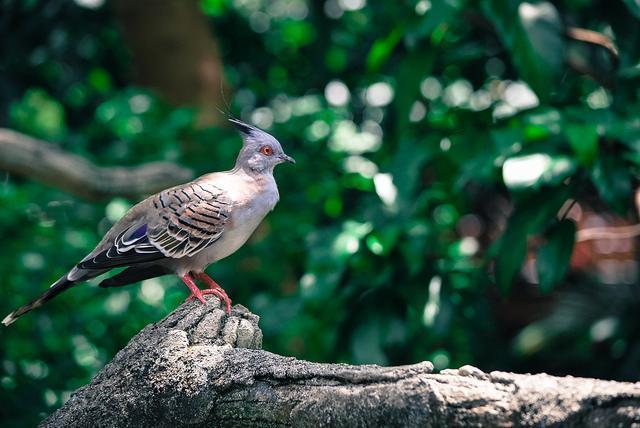How many eyes do you see?
Give a very brief answer. 1. 